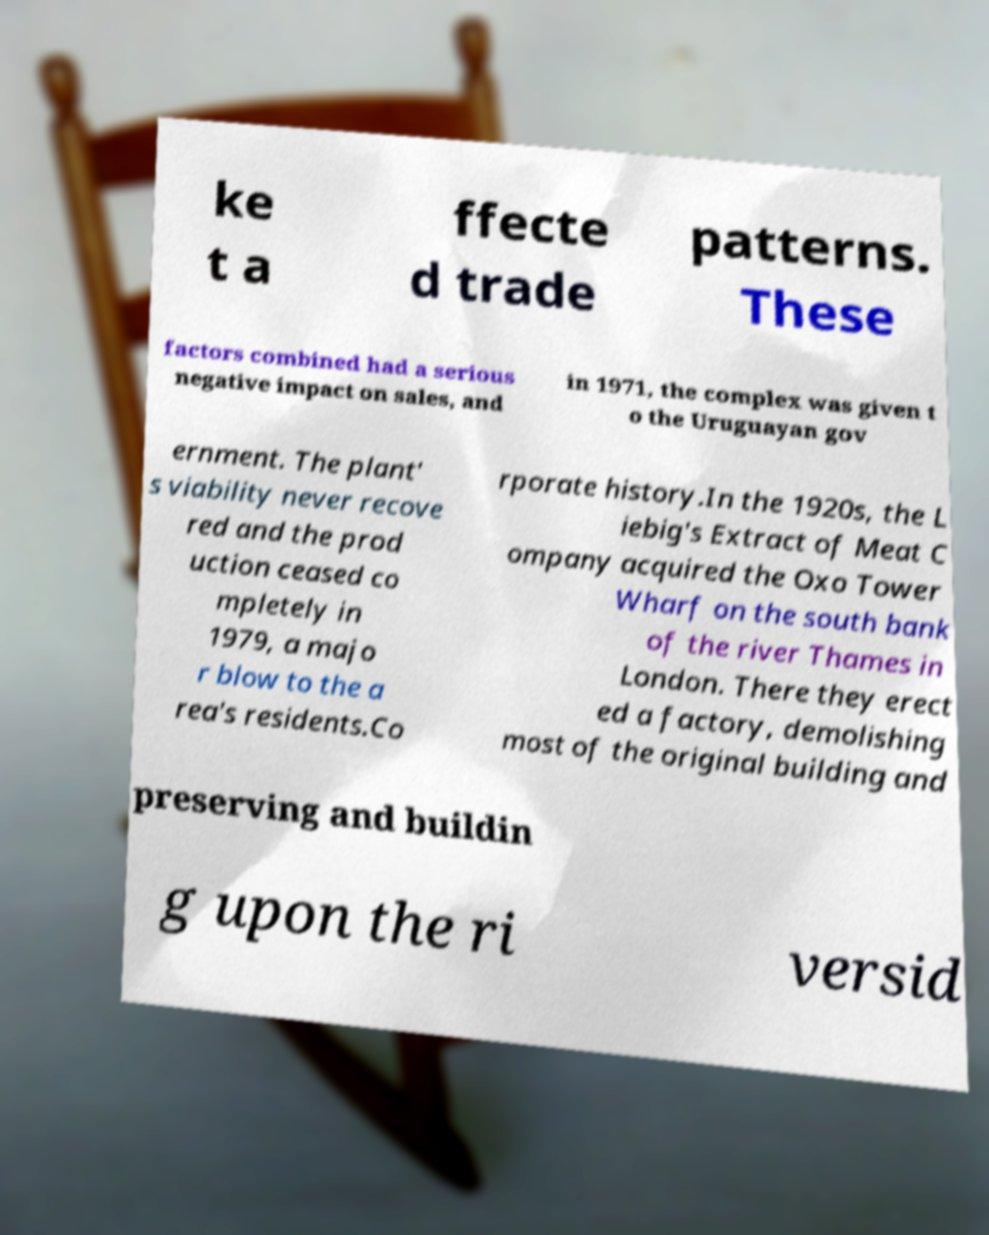Can you read and provide the text displayed in the image?This photo seems to have some interesting text. Can you extract and type it out for me? ke t a ffecte d trade patterns. These factors combined had a serious negative impact on sales, and in 1971, the complex was given t o the Uruguayan gov ernment. The plant' s viability never recove red and the prod uction ceased co mpletely in 1979, a majo r blow to the a rea's residents.Co rporate history.In the 1920s, the L iebig's Extract of Meat C ompany acquired the Oxo Tower Wharf on the south bank of the river Thames in London. There they erect ed a factory, demolishing most of the original building and preserving and buildin g upon the ri versid 